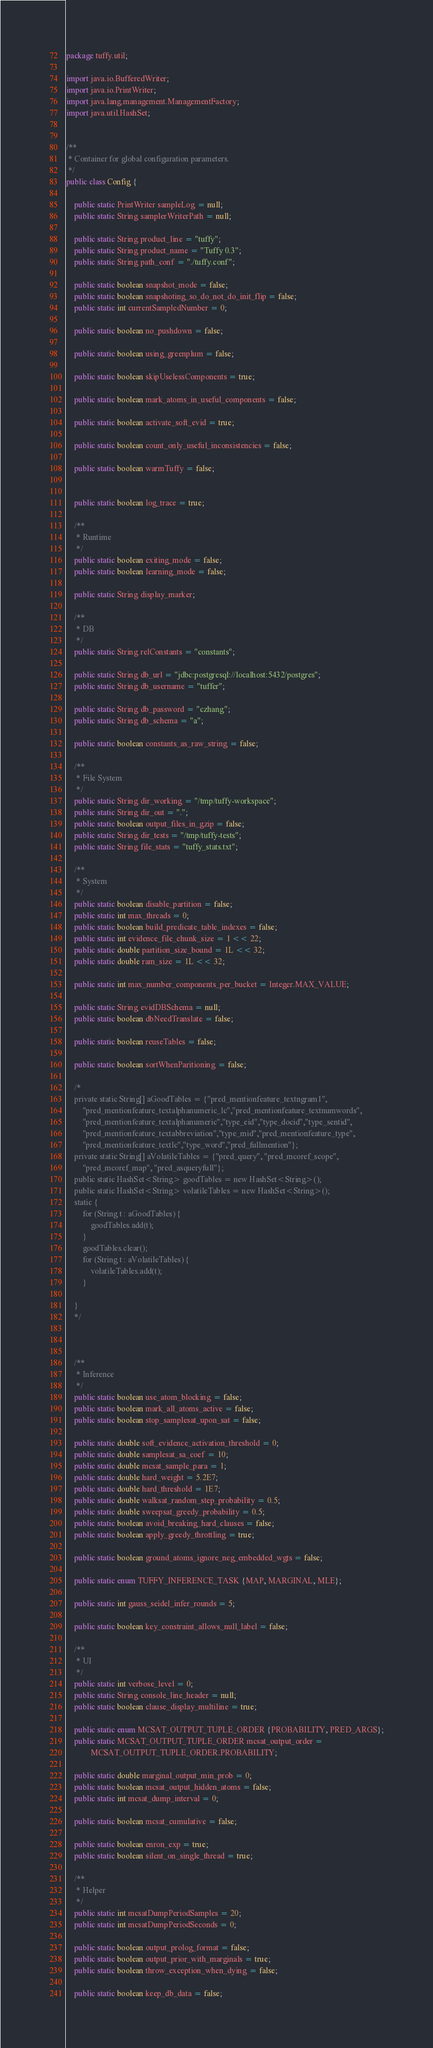Convert code to text. <code><loc_0><loc_0><loc_500><loc_500><_Java_>package tuffy.util;

import java.io.BufferedWriter;
import java.io.PrintWriter;
import java.lang.management.ManagementFactory;
import java.util.HashSet;


/**
 * Container for global configuration parameters.
 */
public class Config {

	public static PrintWriter sampleLog = null;
	public static String samplerWriterPath = null;
	
	public static String product_line = "tuffy";
	public static String product_name = "Tuffy 0.3";
	public static String path_conf = "./tuffy.conf";

	public static boolean snapshot_mode = false;
	public static boolean snapshoting_so_do_not_do_init_flip = false;
	public static int currentSampledNumber = 0;

	public static boolean no_pushdown = false;
	
	public static boolean using_greenplum = false;

	public static boolean skipUselessComponents = true;
	
	public static boolean mark_atoms_in_useful_components = false;

	public static boolean activate_soft_evid = true;
	
	public static boolean count_only_useful_inconsistencies = false;

	public static boolean warmTuffy = false;
	

	public static boolean log_trace = true;
	
	/**
	 * Runtime
	 */
	public static boolean exiting_mode = false;
	public static boolean learning_mode = false;

	public static String display_marker;

	/**
	 * DB
	 */
	public static String relConstants = "constants";

	public static String db_url = "jdbc:postgresql://localhost:5432/postgres";
	public static String db_username = "tuffer";

	public static String db_password = "czhang";
	public static String db_schema = "a";

	public static boolean constants_as_raw_string = false;

	/**
	 * File System
	 */
	public static String dir_working = "/tmp/tuffy-workspace";
	public static String dir_out = ".";
	public static boolean output_files_in_gzip = false;
	public static String dir_tests = "/tmp/tuffy-tests";
	public static String file_stats = "tuffy_stats.txt";

	/**
	 * System
	 */
	public static boolean disable_partition = false;
	public static int max_threads = 0;
	public static boolean build_predicate_table_indexes = false;
	public static int evidence_file_chunk_size = 1 << 22;
	public static double partition_size_bound = 1L << 32;
	public static double ram_size = 1L << 32;
	
	public static int max_number_components_per_bucket = Integer.MAX_VALUE;

	public static String evidDBSchema = null;
	public static boolean dbNeedTranslate = false;

	public static boolean reuseTables = false;

	public static boolean sortWhenParitioning = false;

	/*
	private static String[] aGoodTables = {"pred_mentionfeature_textngram1",
		"pred_mentionfeature_textalphanumeric_lc","pred_mentionfeature_textnumwords",
		"pred_mentionfeature_textalphanumeric","type_eid","type_docid","type_sentid",
		"pred_mentionfeature_textabbreviation","type_mid","pred_mentionfeature_type",
		"pred_mentionfeature_textlc","type_word","pred_fullmention"};
	private static String[] aVolatileTables = {"pred_query", "pred_mcoref_scope", 
		"pred_mcoref_map", "pred_asqueryfull"}; 
	public static HashSet<String> goodTables = new HashSet<String>();
	public static HashSet<String> volatileTables = new HashSet<String>();
	static {
		for (String t : aGoodTables) {
			goodTables.add(t);
		}
		goodTables.clear();
		for (String t : aVolatileTables) {
			volatileTables.add(t);
		}
		
	}
	*/



	/**
	 * Inference
	 */
	public static boolean use_atom_blocking = false;
	public static boolean mark_all_atoms_active = false;
	public static boolean stop_samplesat_upon_sat = false;

	public static double soft_evidence_activation_threshold = 0;
	public static double samplesat_sa_coef = 10;
	public static double mcsat_sample_para = 1;
	public static double hard_weight = 5.2E7;
	public static double hard_threshold = 1E7;
	public static double walksat_random_step_probability = 0.5;
	public static double sweepsat_greedy_probability = 0.5;
	public static boolean avoid_breaking_hard_clauses = false;
	public static boolean apply_greedy_throttling = true;

	public static boolean ground_atoms_ignore_neg_embedded_wgts = false;
	
	public static enum TUFFY_INFERENCE_TASK {MAP, MARGINAL, MLE};

	public static int gauss_seidel_infer_rounds = 5;
	
	public static boolean key_constraint_allows_null_label = false;

	/**
	 * UI
	 */
	public static int verbose_level = 0;
	public static String console_line_header = null;
	public static boolean clause_display_multiline = true;

	public static enum MCSAT_OUTPUT_TUPLE_ORDER {PROBABILITY, PRED_ARGS};
	public static MCSAT_OUTPUT_TUPLE_ORDER mcsat_output_order =
			MCSAT_OUTPUT_TUPLE_ORDER.PROBABILITY;

	public static double marginal_output_min_prob = 0;
	public static boolean mcsat_output_hidden_atoms = false;
	public static int mcsat_dump_interval = 0;
	
	public static boolean mcsat_cumulative = false;

	public static boolean enron_exp = true;
	public static boolean silent_on_single_thread = true;
	
	/**
	 * Helper
	 */
	public static int mcsatDumpPeriodSamples = 20;
	public static int mcsatDumpPeriodSeconds = 0;

	public static boolean output_prolog_format = false;
	public static boolean output_prior_with_marginals = true;
	public static boolean throw_exception_when_dying = false;

	public static boolean keep_db_data = false;
</code> 